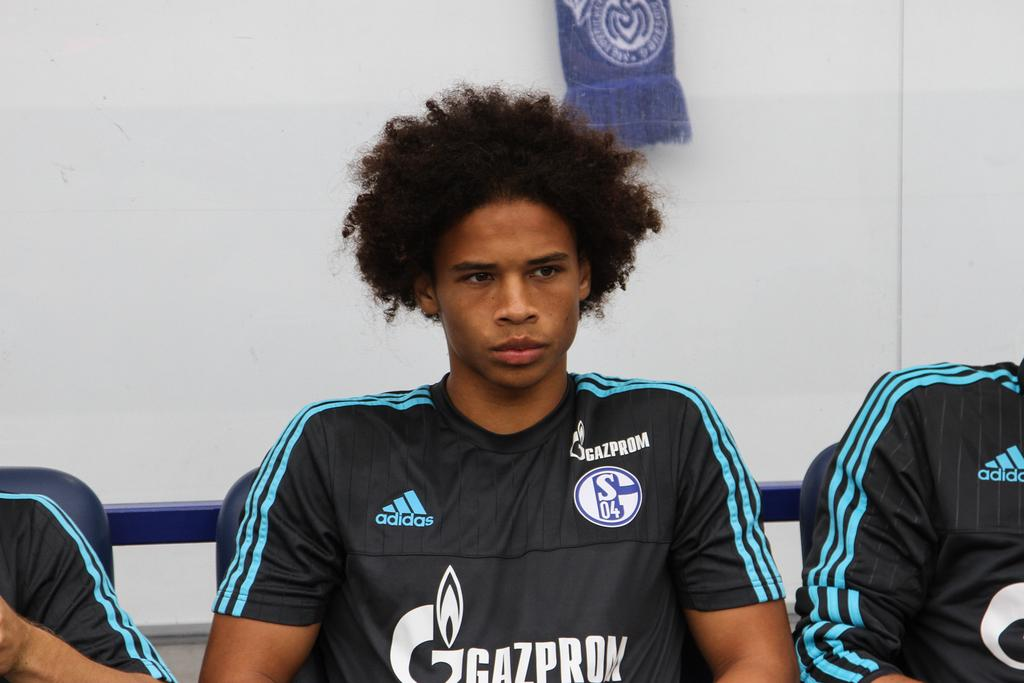<image>
Summarize the visual content of the image. A Gazprom player with an afro sits looking upset while wearing the charcoal and teal jersey. 